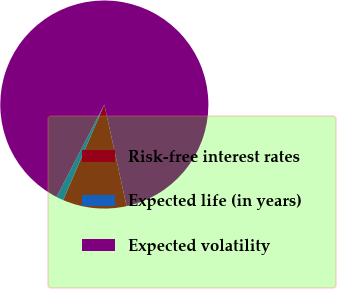<chart> <loc_0><loc_0><loc_500><loc_500><pie_chart><fcel>Risk-free interest rates<fcel>Expected life (in years)<fcel>Expected volatility<nl><fcel>9.91%<fcel>1.12%<fcel>88.97%<nl></chart> 